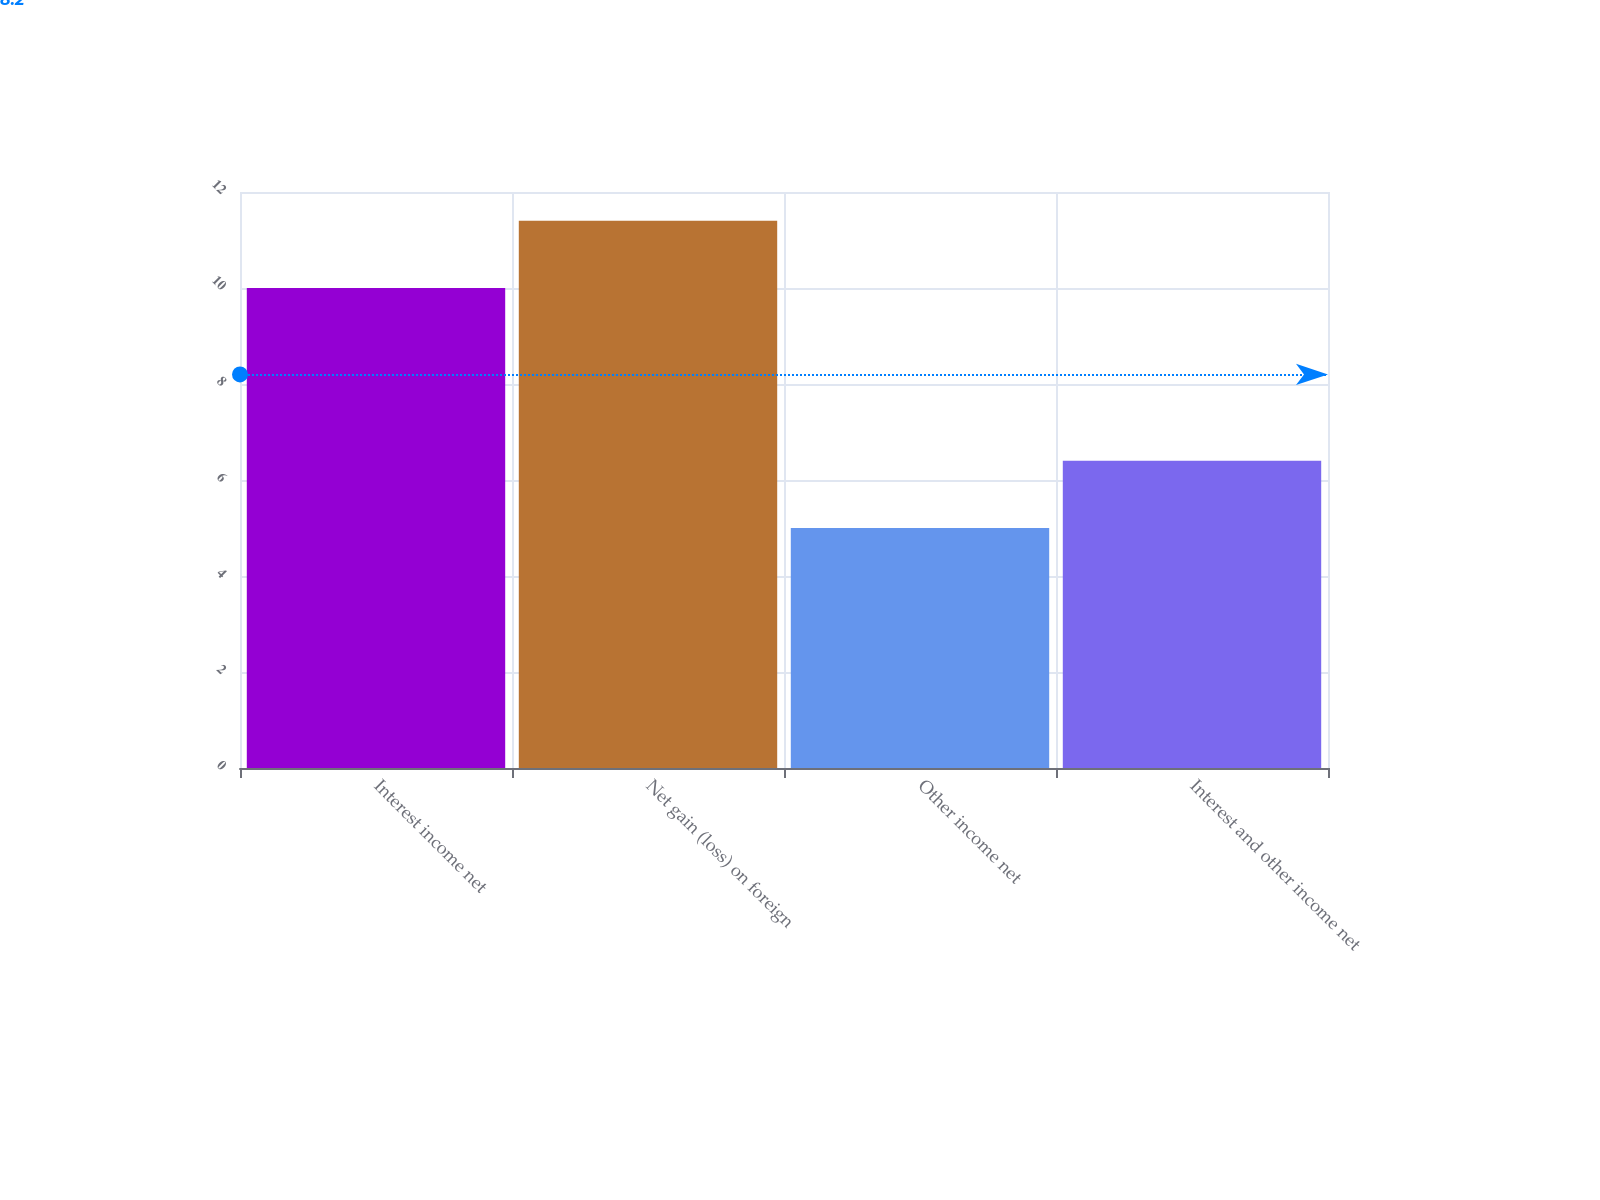Convert chart. <chart><loc_0><loc_0><loc_500><loc_500><bar_chart><fcel>Interest income net<fcel>Net gain (loss) on foreign<fcel>Other income net<fcel>Interest and other income net<nl><fcel>10<fcel>11.4<fcel>5<fcel>6.4<nl></chart> 